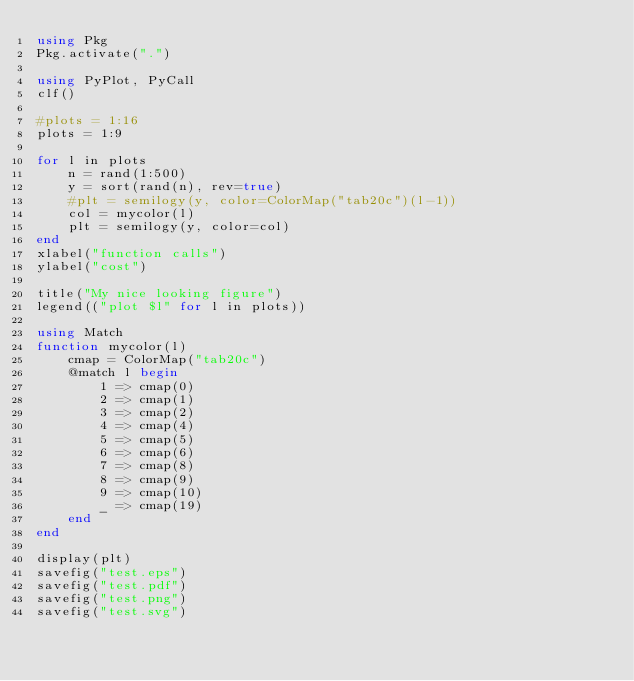<code> <loc_0><loc_0><loc_500><loc_500><_Julia_>using Pkg
Pkg.activate(".")

using PyPlot, PyCall
clf()

#plots = 1:16
plots = 1:9

for l in plots
    n = rand(1:500)
    y = sort(rand(n), rev=true)
    #plt = semilogy(y, color=ColorMap("tab20c")(l-1))
    col = mycolor(l)
    plt = semilogy(y, color=col)
end
xlabel("function calls")
ylabel("cost")

title("My nice looking figure")
legend(("plot $l" for l in plots))

using Match
function mycolor(l)
    cmap = ColorMap("tab20c")
    @match l begin
        1 => cmap(0)
        2 => cmap(1)
        3 => cmap(2)
        4 => cmap(4)
        5 => cmap(5)
        6 => cmap(6)
        7 => cmap(8)
        8 => cmap(9)
        9 => cmap(10)
        _ => cmap(19)
    end
end

display(plt)
savefig("test.eps")
savefig("test.pdf")
savefig("test.png")
savefig("test.svg")</code> 